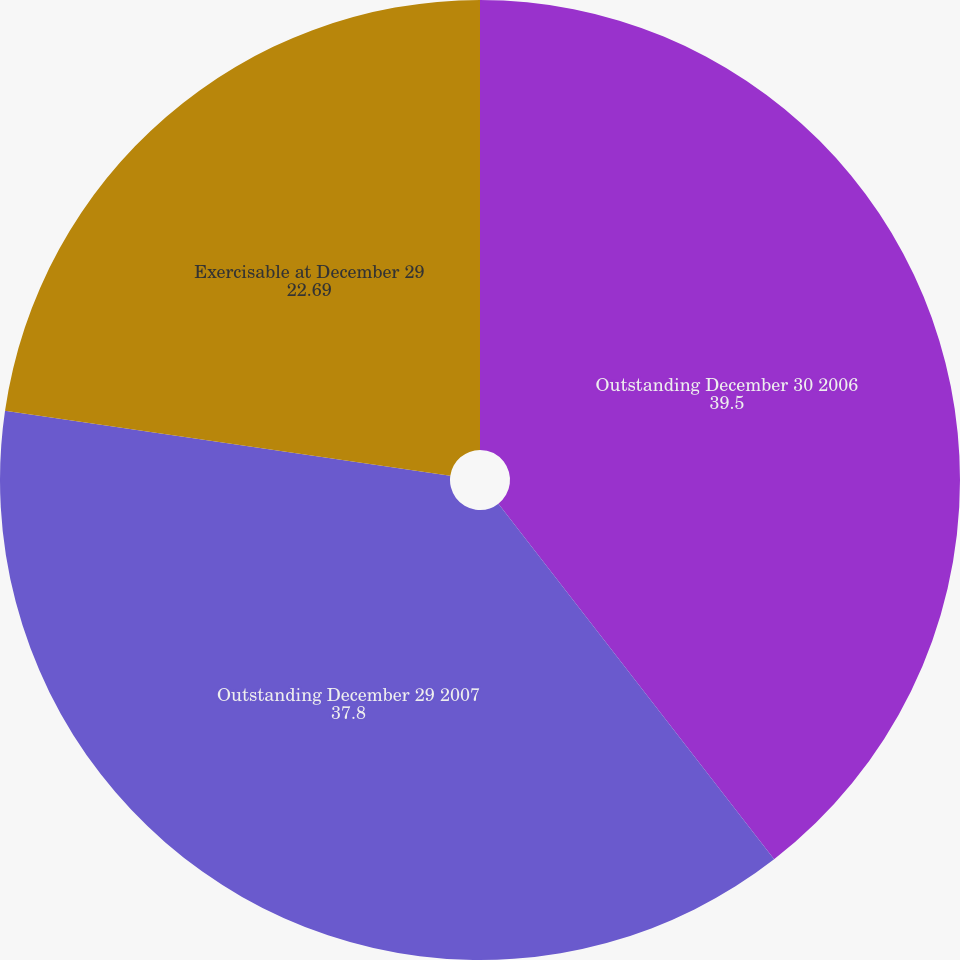Convert chart to OTSL. <chart><loc_0><loc_0><loc_500><loc_500><pie_chart><fcel>Outstanding December 30 2006<fcel>Outstanding December 29 2007<fcel>Exercisable at December 29<nl><fcel>39.5%<fcel>37.8%<fcel>22.69%<nl></chart> 